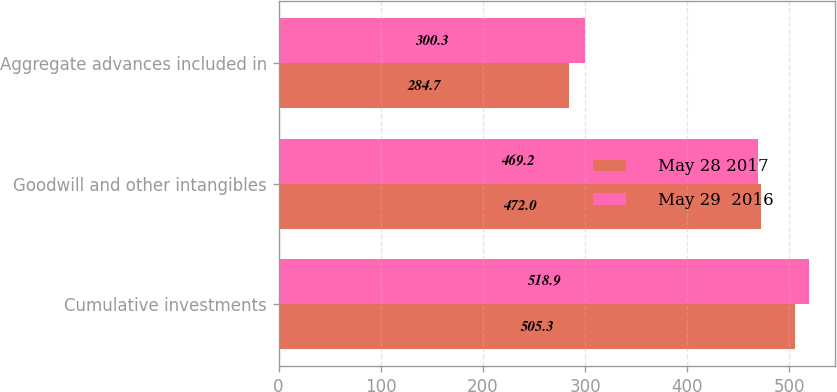Convert chart to OTSL. <chart><loc_0><loc_0><loc_500><loc_500><stacked_bar_chart><ecel><fcel>Cumulative investments<fcel>Goodwill and other intangibles<fcel>Aggregate advances included in<nl><fcel>May 28 2017<fcel>505.3<fcel>472<fcel>284.7<nl><fcel>May 29  2016<fcel>518.9<fcel>469.2<fcel>300.3<nl></chart> 